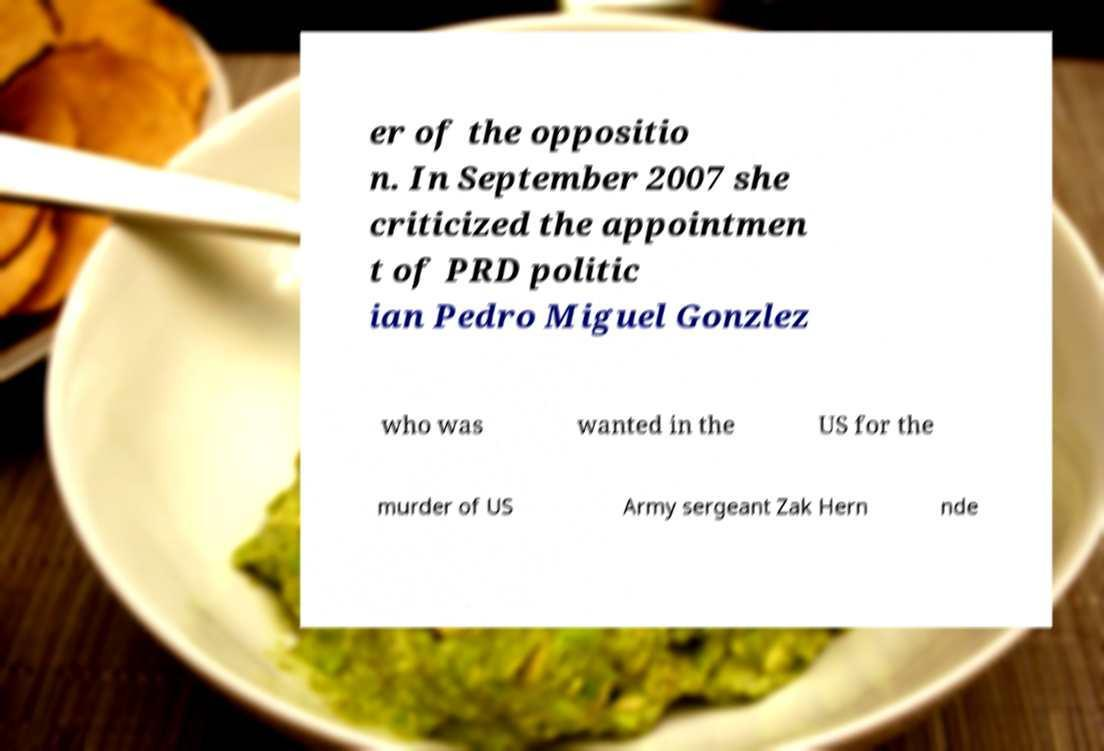Can you accurately transcribe the text from the provided image for me? er of the oppositio n. In September 2007 she criticized the appointmen t of PRD politic ian Pedro Miguel Gonzlez who was wanted in the US for the murder of US Army sergeant Zak Hern nde 